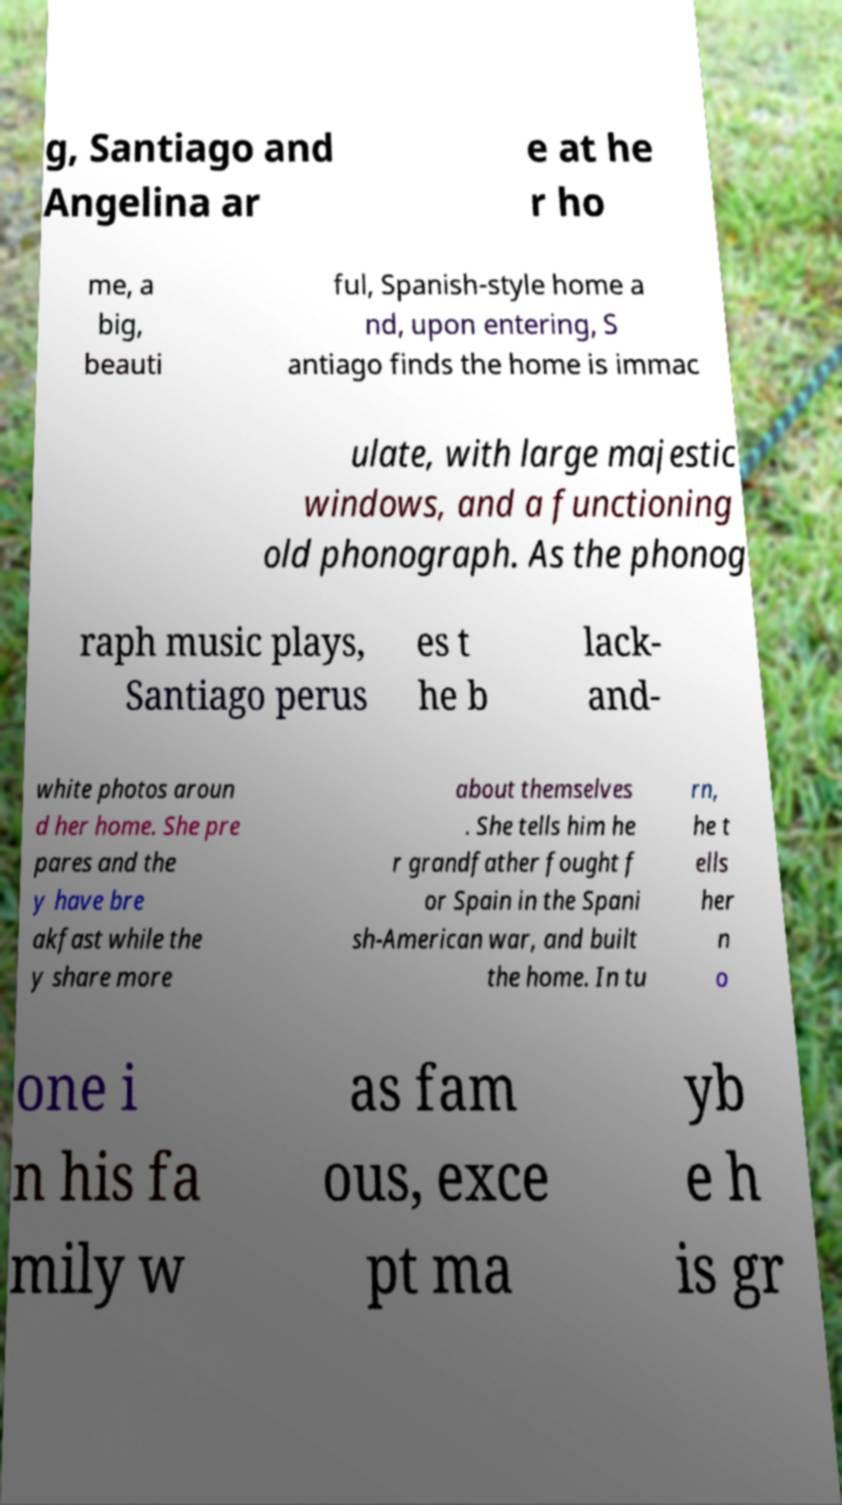Can you accurately transcribe the text from the provided image for me? g, Santiago and Angelina ar e at he r ho me, a big, beauti ful, Spanish-style home a nd, upon entering, S antiago finds the home is immac ulate, with large majestic windows, and a functioning old phonograph. As the phonog raph music plays, Santiago perus es t he b lack- and- white photos aroun d her home. She pre pares and the y have bre akfast while the y share more about themselves . She tells him he r grandfather fought f or Spain in the Spani sh-American war, and built the home. In tu rn, he t ells her n o one i n his fa mily w as fam ous, exce pt ma yb e h is gr 